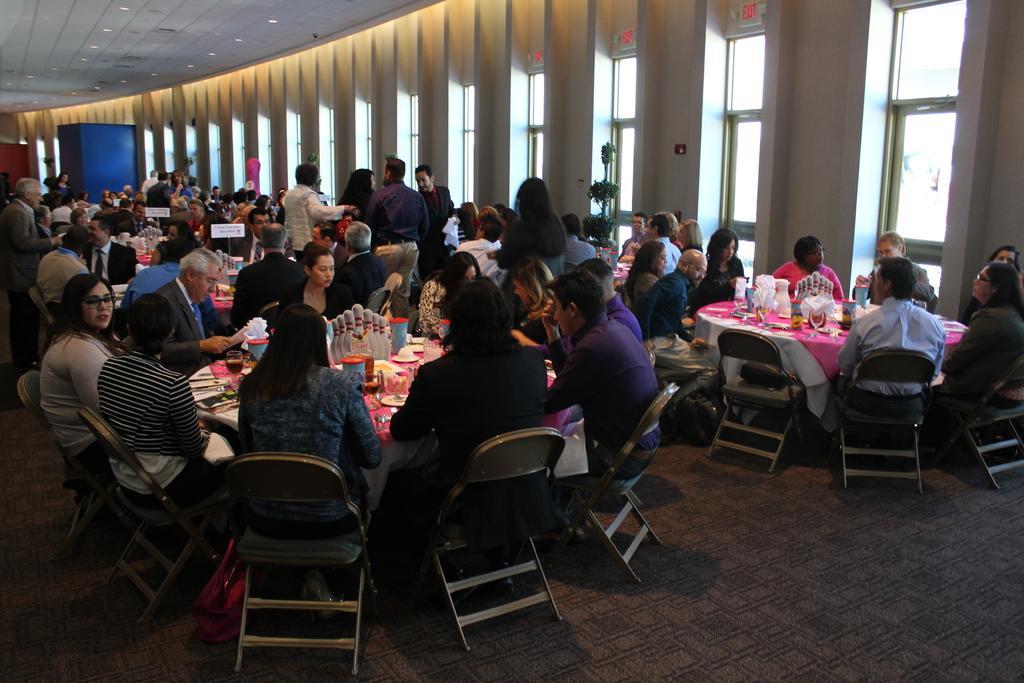How would you summarize this image in a sentence or two? In this image i can see a group of people sitting on chairs around the tables. On the table i can see food items, plates and bowls. In the background i can see windows, plants and few people standing. 